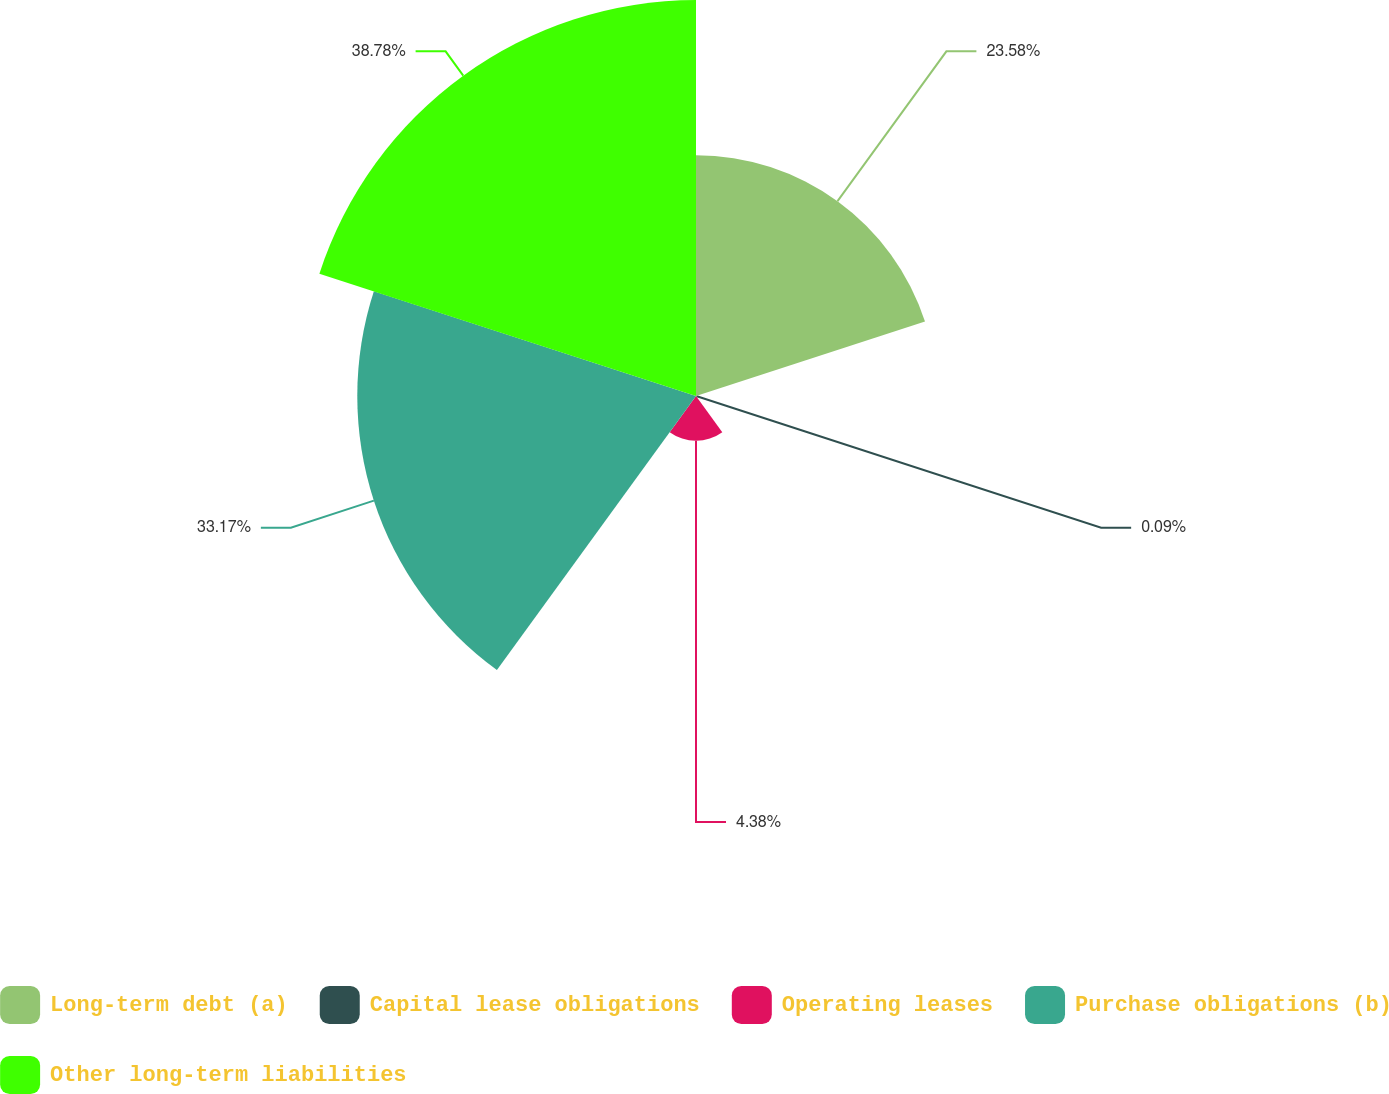<chart> <loc_0><loc_0><loc_500><loc_500><pie_chart><fcel>Long-term debt (a)<fcel>Capital lease obligations<fcel>Operating leases<fcel>Purchase obligations (b)<fcel>Other long-term liabilities<nl><fcel>23.58%<fcel>0.09%<fcel>4.38%<fcel>33.17%<fcel>38.78%<nl></chart> 